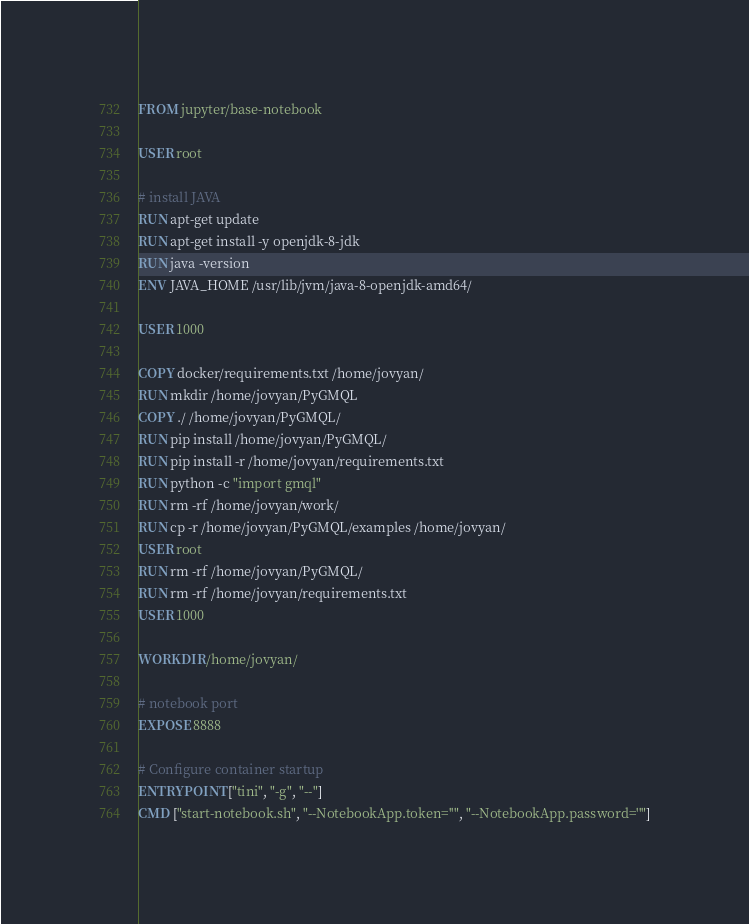Convert code to text. <code><loc_0><loc_0><loc_500><loc_500><_Dockerfile_>FROM jupyter/base-notebook

USER root

# install JAVA
RUN apt-get update
RUN apt-get install -y openjdk-8-jdk
RUN java -version
ENV JAVA_HOME /usr/lib/jvm/java-8-openjdk-amd64/

USER 1000

COPY docker/requirements.txt /home/jovyan/
RUN mkdir /home/jovyan/PyGMQL
COPY ./ /home/jovyan/PyGMQL/
RUN pip install /home/jovyan/PyGMQL/
RUN pip install -r /home/jovyan/requirements.txt
RUN python -c "import gmql"
RUN rm -rf /home/jovyan/work/
RUN cp -r /home/jovyan/PyGMQL/examples /home/jovyan/
USER root
RUN rm -rf /home/jovyan/PyGMQL/
RUN rm -rf /home/jovyan/requirements.txt
USER 1000

WORKDIR /home/jovyan/

# notebook port
EXPOSE 8888

# Configure container startup
ENTRYPOINT ["tini", "-g", "--"]
CMD ["start-notebook.sh", "--NotebookApp.token=''", "--NotebookApp.password=''"]
</code> 